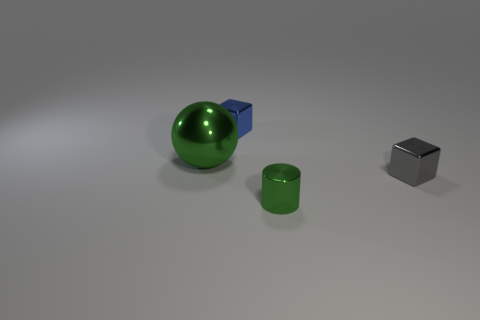There is a tiny gray object right of the large green ball; is it the same shape as the tiny blue thing?
Your response must be concise. Yes. How many blocks have the same size as the cylinder?
Make the answer very short. 2. The tiny thing that is both behind the tiny green metal cylinder and in front of the big metal object is what color?
Your answer should be compact. Gray. Is the number of green things less than the number of shiny things?
Offer a very short reply. Yes. There is a large metal object; is its color the same as the cylinder that is in front of the blue shiny cube?
Provide a succinct answer. Yes. Are there the same number of shiny cylinders behind the green ball and small gray metallic objects to the right of the blue block?
Ensure brevity in your answer.  No. How many tiny gray objects are the same shape as the tiny blue thing?
Offer a terse response. 1. Is there a small red sphere?
Provide a short and direct response. No. There is a green cylinder that is the same size as the blue object; what is it made of?
Offer a terse response. Metal. Is there a small green cylinder made of the same material as the tiny gray thing?
Keep it short and to the point. Yes. 